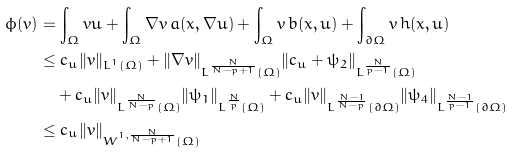Convert formula to latex. <formula><loc_0><loc_0><loc_500><loc_500>\phi ( v ) & = \int _ { \Omega } v u + \int _ { \Omega } \nabla v \, a ( x , \nabla u ) + \int _ { \Omega } v \, b ( x , u ) + \int _ { \partial \Omega } v \, h ( x , u ) \\ & \leq c _ { u } \| v \| _ { L ^ { 1 } ( \Omega ) } + \| \nabla v \| _ { L ^ { \frac { N } { N - p + 1 } } ( \Omega ) } \| c _ { u } + \psi _ { 2 } \| _ { L ^ { \frac { N } { p - 1 } } ( \Omega ) } \\ & \quad + c _ { u } \| v \| _ { L ^ { \frac { N } { N - p } } ( \Omega ) } \| \psi _ { 1 } \| _ { L ^ { \frac { N } { p } } ( \Omega ) } + c _ { u } \| v \| _ { L ^ { \frac { N - 1 } { N - p } } ( \partial \Omega ) } \| \psi _ { 4 } \| _ { L ^ { \frac { N - 1 } { p - 1 } } ( \partial \Omega ) } \\ & \leq c _ { u } \| v \| _ { W ^ { 1 , \frac { N } { N - p + 1 } } ( \Omega ) }</formula> 